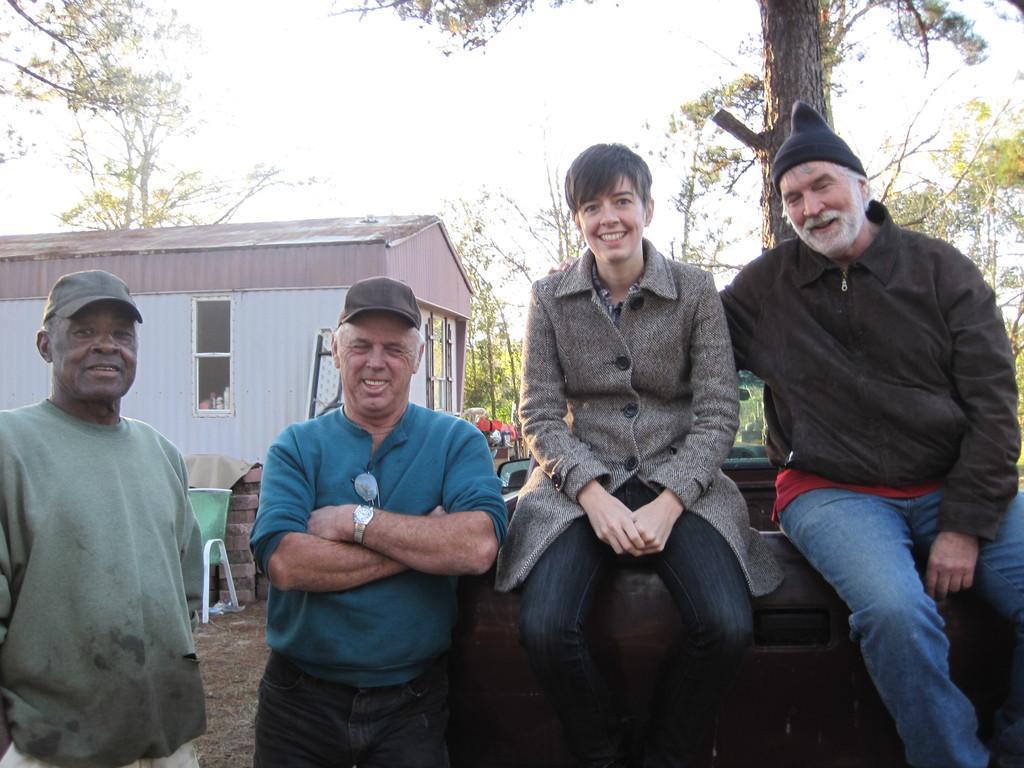Describe this image in one or two sentences. In this image we can see two people sitting, next to them there are people standing. In the background there is a shed and we can see trees. There is sky. 